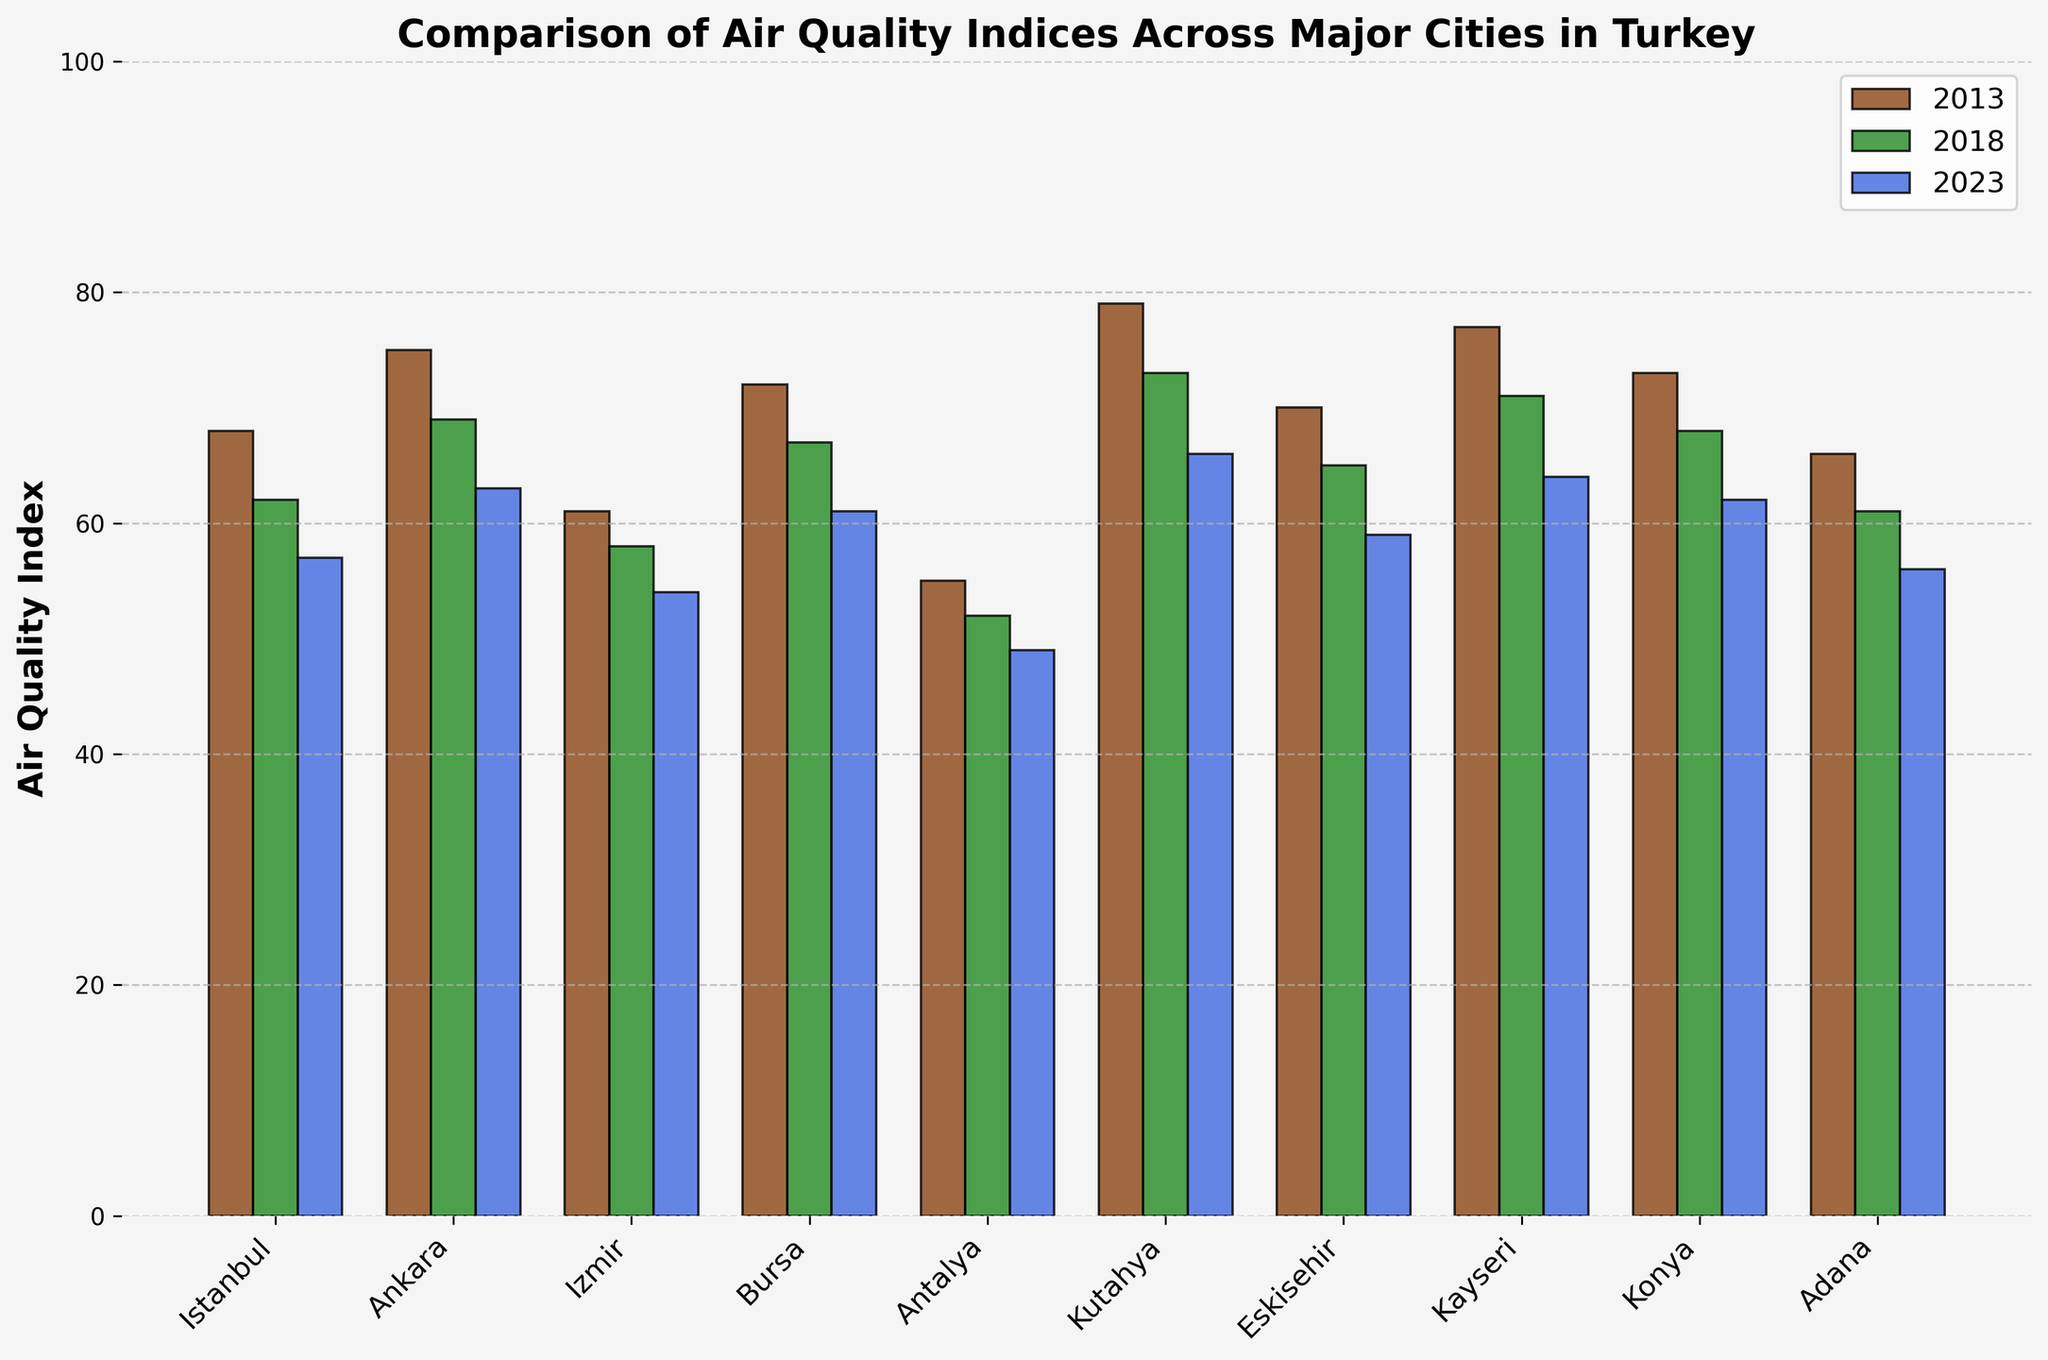What city had the highest air quality index in 2013? The bar chart shows air quality indices for different cities, with the highest bar indicating the highest index. In 2013, Kutahya had the tallest bar.
Answer: Kutahya Which city saw the largest improvement in air quality index from 2013 to 2023? To find this, calculate the difference between the 2013 and 2023 indices for each city and compare the results. Kutahya had the largest drop from 79 to 66, which is a 13-point improvement.
Answer: Kutahya In 2018, which city had the second lowest air quality index? The second lowest bar in 2018 represents the second lowest index. Antalya has the lowest, and Izmir has the second lowest in 2018.
Answer: Izmir Compare the air quality index of Istanbul and Ankara in 2023. Which city has a better air quality index? In 2023, the bar for Istanbul is shorter than for Ankara, indicating a lower (better) index.
Answer: Istanbul What is the average air quality index of Bursa across the three years? Calculate the average by summing the values for Bursa (72 in 2013, 67 in 2018, 61 in 2023) and divide by 3. The average is (72+67+61)/3 = 66.67.
Answer: 66.67 Which city had a consistent decrease in air quality index from 2013 to 2023? Check the bars for each year to see if any city's values continuously decrease. Bursa, for example, decreased from 72 to 67 and then to 61.
Answer: Bursa Between Izmir and Eskisehir, which city had a higher air quality index in 2018? Compare the heights of the bars for both cities in 2018. Izmir had a lower bar (58) than Eskisehir (65).
Answer: Eskisehir What is the total air quality index for Antalya over the three years? Sum the values for Antalya in 2013, 2018, and 2023 (55+52+49). The total is 156.
Answer: 156 Which city has had the least improvement in air quality from 2013 to 2023? Calculate the improvement for each city by subtracting the 2023 values from the 2013 values. The city with the smallest difference is Antalya, improving by just 6 points.
Answer: Antalya How does the air quality index of Kutahya in 2023 compare to Eskisehir in 2018? Look at the bars for Kutahya in 2023 and Eskisehir in 2018. Kutahya in 2023 is slightly higher than Eskisehir in 2018.
Answer: Higher 